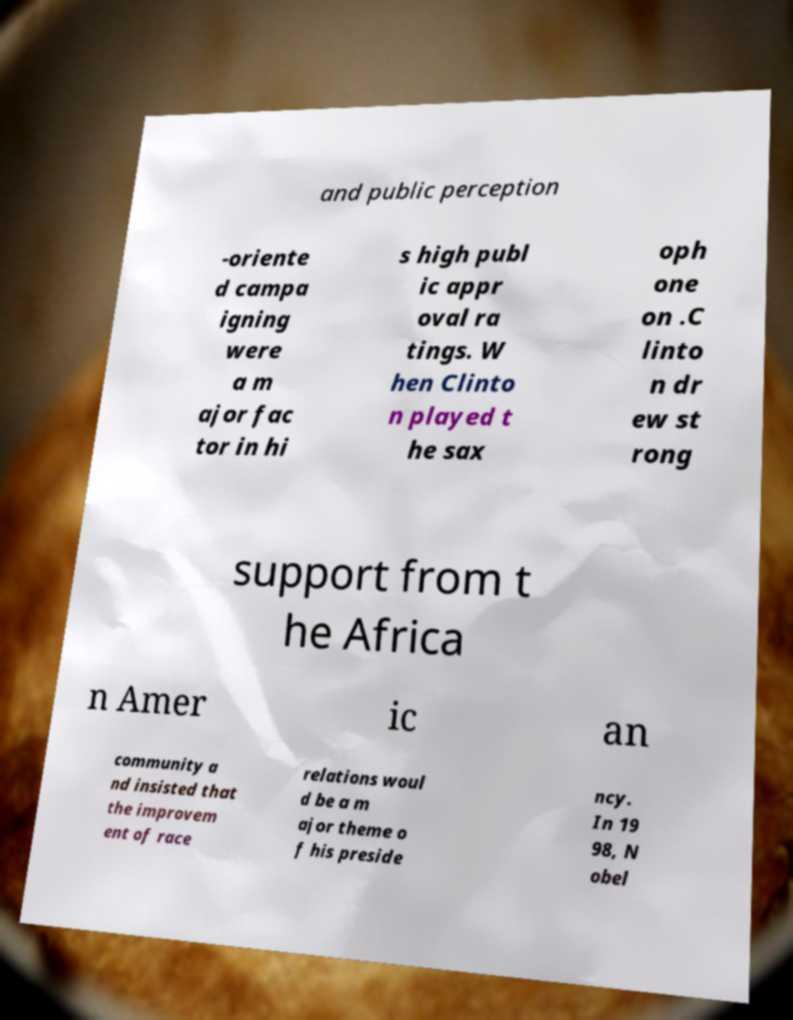Can you read and provide the text displayed in the image?This photo seems to have some interesting text. Can you extract and type it out for me? and public perception -oriente d campa igning were a m ajor fac tor in hi s high publ ic appr oval ra tings. W hen Clinto n played t he sax oph one on .C linto n dr ew st rong support from t he Africa n Amer ic an community a nd insisted that the improvem ent of race relations woul d be a m ajor theme o f his preside ncy. In 19 98, N obel 